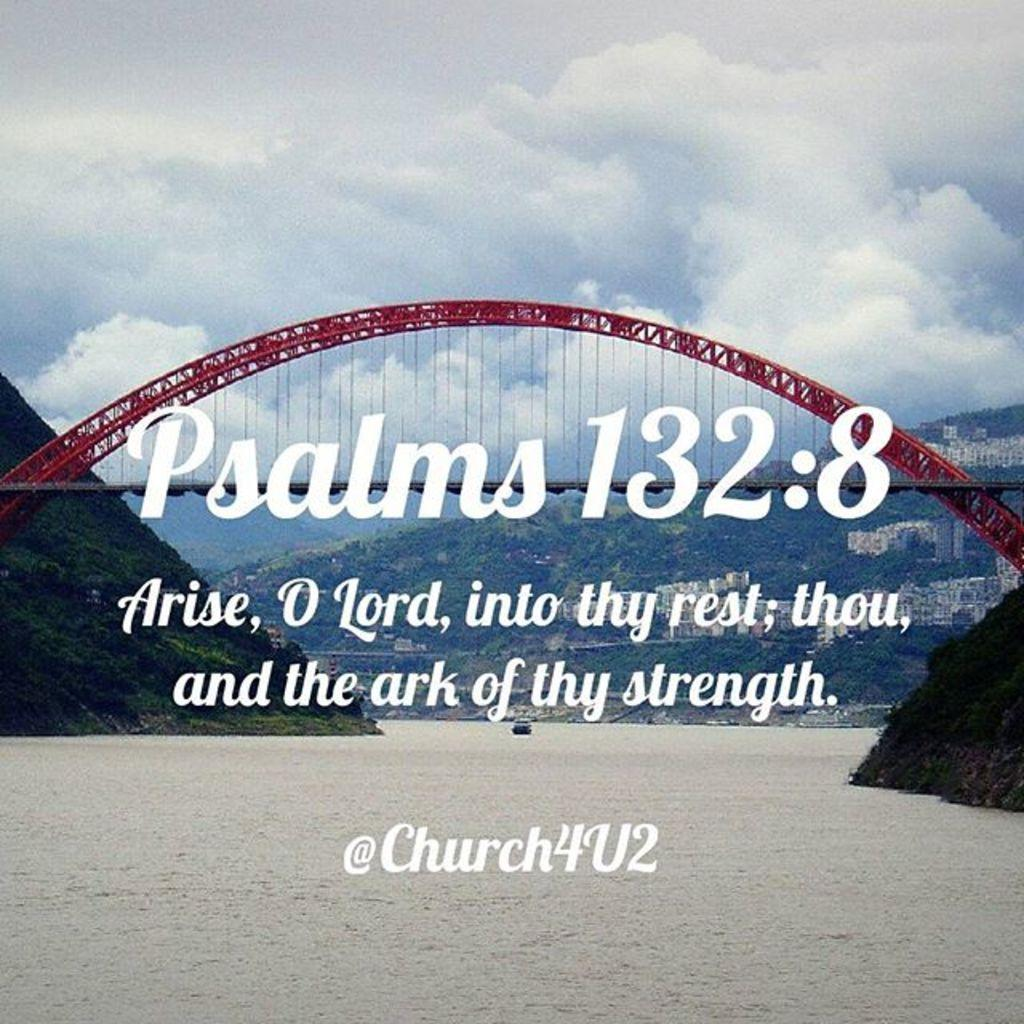<image>
Summarize the visual content of the image. A picture of a bridge in the clouds with the words Psalms132:8 Arise o lord into thy rest; 